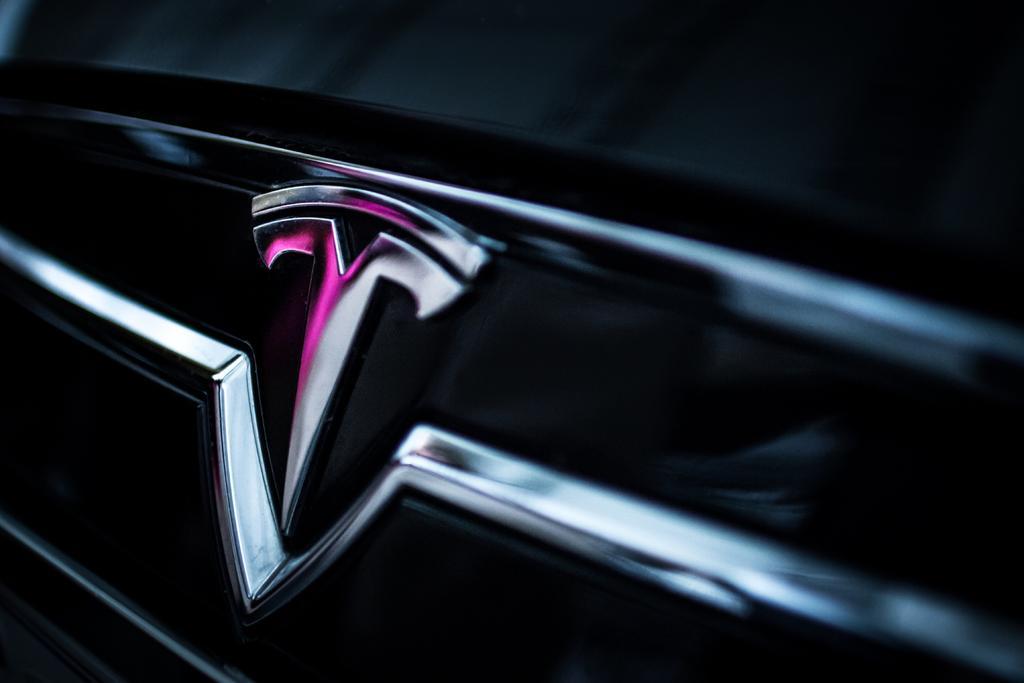Please provide a concise description of this image. This is a black car and we can see the logo of a car here. 